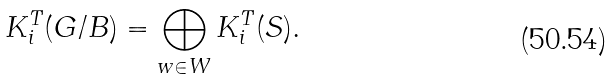<formula> <loc_0><loc_0><loc_500><loc_500>K ^ { T } _ { i } ( G / B ) = \bigoplus _ { w \in W } K ^ { T } _ { i } ( S ) .</formula> 